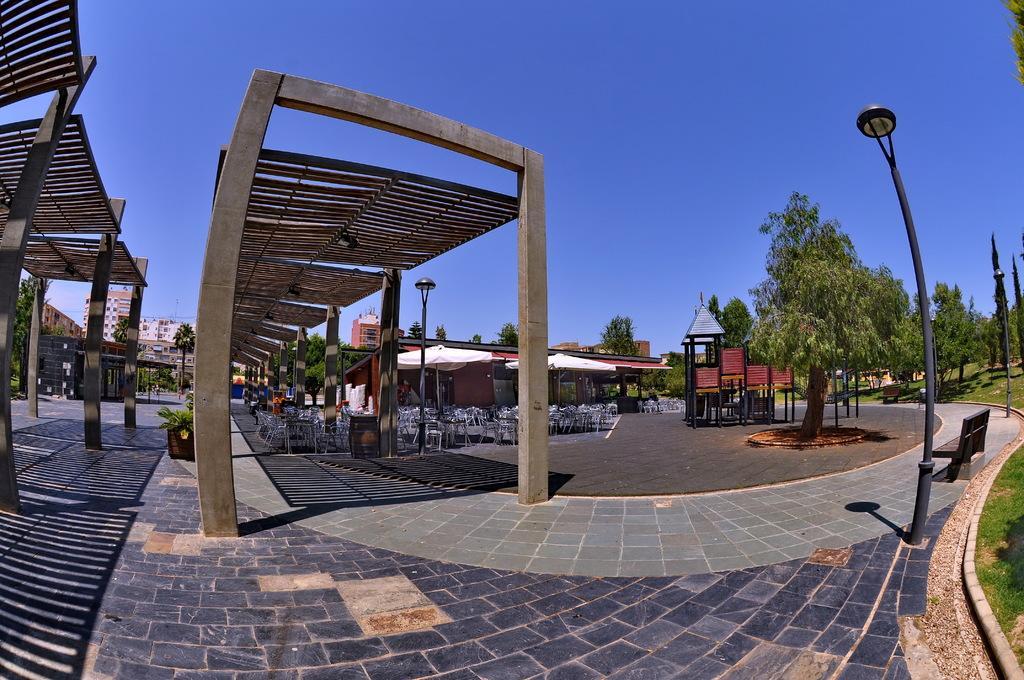In one or two sentences, can you explain what this image depicts? In this picture we can observe a building. There are some chairs and tables. On the right side there is a black color pole. We can observe some trees. There is a bench here. In the background there is a sky. 